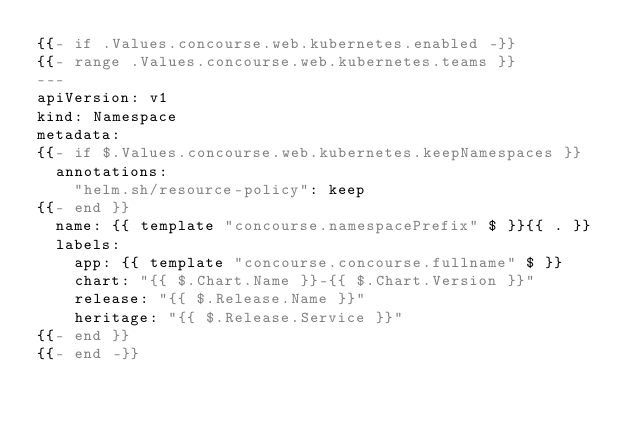<code> <loc_0><loc_0><loc_500><loc_500><_YAML_>{{- if .Values.concourse.web.kubernetes.enabled -}}
{{- range .Values.concourse.web.kubernetes.teams }}
---
apiVersion: v1
kind: Namespace
metadata:
{{- if $.Values.concourse.web.kubernetes.keepNamespaces }}
  annotations:
    "helm.sh/resource-policy": keep
{{- end }}
  name: {{ template "concourse.namespacePrefix" $ }}{{ . }}
  labels:
    app: {{ template "concourse.concourse.fullname" $ }}
    chart: "{{ $.Chart.Name }}-{{ $.Chart.Version }}"
    release: "{{ $.Release.Name }}"
    heritage: "{{ $.Release.Service }}"
{{- end }}
{{- end -}}
</code> 